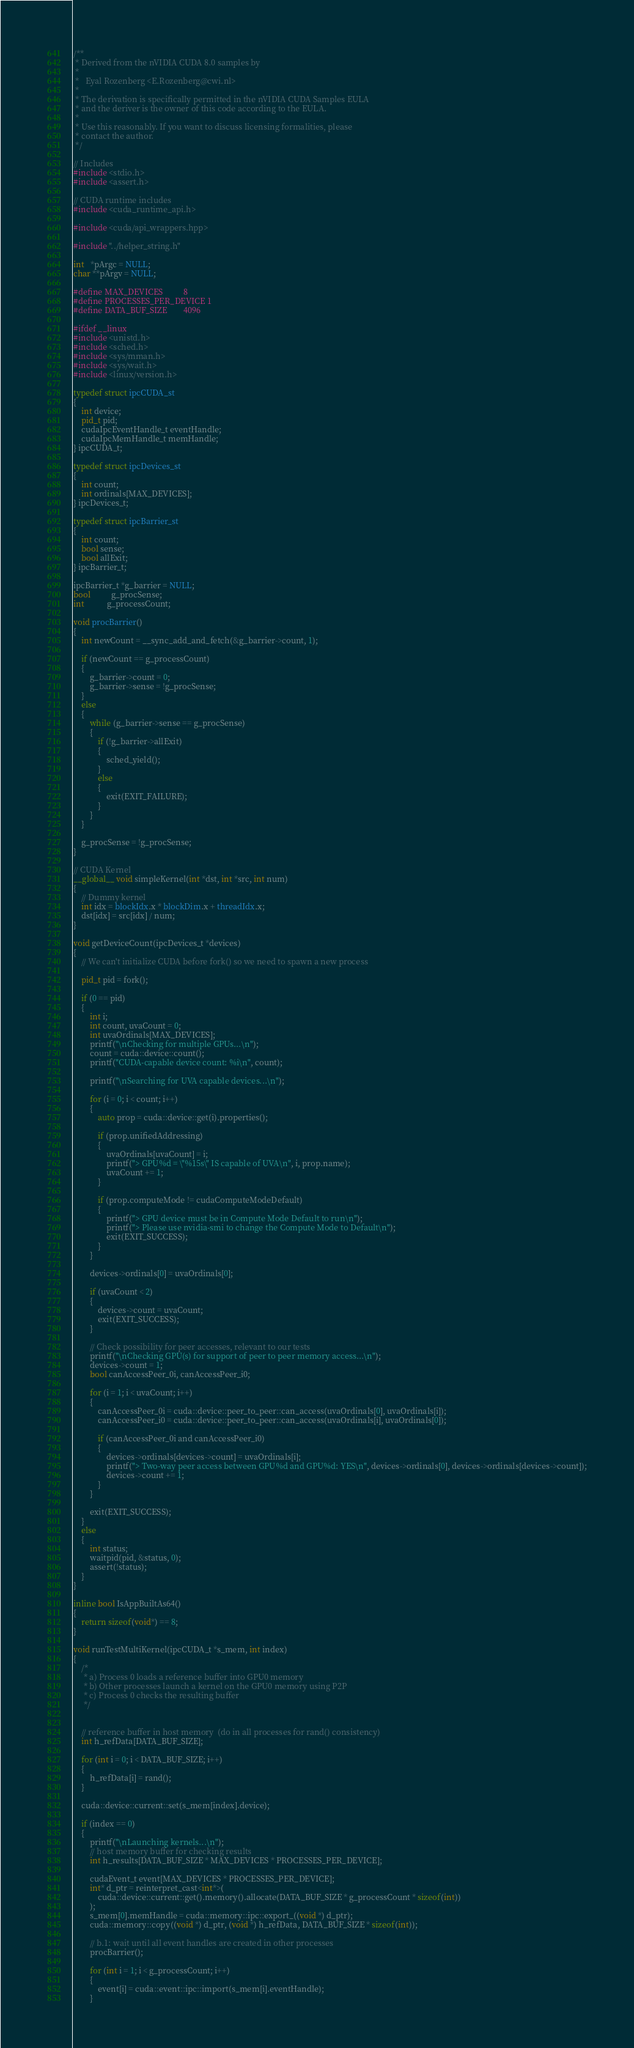Convert code to text. <code><loc_0><loc_0><loc_500><loc_500><_Cuda_>/**
 * Derived from the nVIDIA CUDA 8.0 samples by
 *
 *   Eyal Rozenberg <E.Rozenberg@cwi.nl>
 *
 * The derivation is specifically permitted in the nVIDIA CUDA Samples EULA
 * and the deriver is the owner of this code according to the EULA.
 *
 * Use this reasonably. If you want to discuss licensing formalities, please
 * contact the author.
 */

// Includes
#include <stdio.h>
#include <assert.h>

// CUDA runtime includes
#include <cuda_runtime_api.h>

#include <cuda/api_wrappers.hpp>

#include "../helper_string.h"

int   *pArgc = NULL;
char **pArgv = NULL;

#define MAX_DEVICES          8
#define PROCESSES_PER_DEVICE 1
#define DATA_BUF_SIZE        4096

#ifdef __linux
#include <unistd.h>
#include <sched.h>
#include <sys/mman.h>
#include <sys/wait.h>
#include <linux/version.h>

typedef struct ipcCUDA_st
{
	int device;
	pid_t pid;
	cudaIpcEventHandle_t eventHandle;
	cudaIpcMemHandle_t memHandle;
} ipcCUDA_t;

typedef struct ipcDevices_st
{
	int count;
	int ordinals[MAX_DEVICES];
} ipcDevices_t;

typedef struct ipcBarrier_st
{
	int count;
	bool sense;
	bool allExit;
} ipcBarrier_t;

ipcBarrier_t *g_barrier = NULL;
bool          g_procSense;
int           g_processCount;

void procBarrier()
{
	int newCount = __sync_add_and_fetch(&g_barrier->count, 1);

	if (newCount == g_processCount)
	{
		g_barrier->count = 0;
		g_barrier->sense = !g_procSense;
	}
	else
	{
		while (g_barrier->sense == g_procSense)
		{
			if (!g_barrier->allExit)
			{
				sched_yield();
			}
			else
			{
				exit(EXIT_FAILURE);
			}
		}
	}

	g_procSense = !g_procSense;
}

// CUDA Kernel
__global__ void simpleKernel(int *dst, int *src, int num)
{
	// Dummy kernel
	int idx = blockIdx.x * blockDim.x + threadIdx.x;
	dst[idx] = src[idx] / num;
}

void getDeviceCount(ipcDevices_t *devices)
{
	// We can't initialize CUDA before fork() so we need to spawn a new process

	pid_t pid = fork();

	if (0 == pid)
	{
		int i;
		int count, uvaCount = 0;
		int uvaOrdinals[MAX_DEVICES];
		printf("\nChecking for multiple GPUs...\n");
		count = cuda::device::count();
		printf("CUDA-capable device count: %i\n", count);

		printf("\nSearching for UVA capable devices...\n");

		for (i = 0; i < count; i++)
		{
			auto prop = cuda::device::get(i).properties();

			if (prop.unifiedAddressing)
			{
				uvaOrdinals[uvaCount] = i;
				printf("> GPU%d = \"%15s\" IS capable of UVA\n", i, prop.name);
				uvaCount += 1;
			}

			if (prop.computeMode != cudaComputeModeDefault)
			{
				printf("> GPU device must be in Compute Mode Default to run\n");
				printf("> Please use nvidia-smi to change the Compute Mode to Default\n");
				exit(EXIT_SUCCESS);
			}
		}

		devices->ordinals[0] = uvaOrdinals[0];

		if (uvaCount < 2)
		{
			devices->count = uvaCount;
			exit(EXIT_SUCCESS);
		}

		// Check possibility for peer accesses, relevant to our tests
		printf("\nChecking GPU(s) for support of peer to peer memory access...\n");
		devices->count = 1;
		bool canAccessPeer_0i, canAccessPeer_i0;

		for (i = 1; i < uvaCount; i++)
		{
			canAccessPeer_0i = cuda::device::peer_to_peer::can_access(uvaOrdinals[0], uvaOrdinals[i]);
			canAccessPeer_i0 = cuda::device::peer_to_peer::can_access(uvaOrdinals[i], uvaOrdinals[0]);

			if (canAccessPeer_0i and canAccessPeer_i0)
			{
				devices->ordinals[devices->count] = uvaOrdinals[i];
				printf("> Two-way peer access between GPU%d and GPU%d: YES\n", devices->ordinals[0], devices->ordinals[devices->count]);
				devices->count += 1;
			}
		}

		exit(EXIT_SUCCESS);
	}
	else
	{
		int status;
		waitpid(pid, &status, 0);
		assert(!status);
	}
}

inline bool IsAppBuiltAs64()
{
	return sizeof(void*) == 8;
}

void runTestMultiKernel(ipcCUDA_t *s_mem, int index)
{
	/*
	 * a) Process 0 loads a reference buffer into GPU0 memory
	 * b) Other processes launch a kernel on the GPU0 memory using P2P
	 * c) Process 0 checks the resulting buffer
	 */


	// reference buffer in host memory  (do in all processes for rand() consistency)
	int h_refData[DATA_BUF_SIZE];

	for (int i = 0; i < DATA_BUF_SIZE; i++)
	{
		h_refData[i] = rand();
	}

	cuda::device::current::set(s_mem[index].device);

	if (index == 0)
	{
		printf("\nLaunching kernels...\n");
		// host memory buffer for checking results
		int h_results[DATA_BUF_SIZE * MAX_DEVICES * PROCESSES_PER_DEVICE];

		cudaEvent_t event[MAX_DEVICES * PROCESSES_PER_DEVICE];
		int* d_ptr = reinterpret_cast<int*>(
			cuda::device::current::get().memory().allocate(DATA_BUF_SIZE * g_processCount * sizeof(int))
		);
		s_mem[0].memHandle = cuda::memory::ipc::export_((void *) d_ptr);
		cuda::memory::copy((void *) d_ptr, (void *) h_refData, DATA_BUF_SIZE * sizeof(int));

		// b.1: wait until all event handles are created in other processes
		procBarrier();

		for (int i = 1; i < g_processCount; i++)
		{
			event[i] = cuda::event::ipc::import(s_mem[i].eventHandle);
		}
</code> 